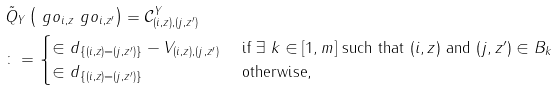Convert formula to latex. <formula><loc_0><loc_0><loc_500><loc_500>& \tilde { Q } _ { Y } \left ( \ g o _ { i , z } \ g o _ { i , z ^ { \prime } } \right ) = \mathcal { C } ^ { Y } _ { ( i , z ) , ( j , z ^ { \prime } ) } \\ & \colon = \begin{cases} \in d _ { \{ ( i , z ) = ( j , z ^ { \prime } ) \} } - V _ { ( i , z ) , ( j , z ^ { \prime } ) } & \text { if } \exists \ k \in [ 1 , m ] \text { such that } ( i , z ) \text { and } ( j , z ^ { \prime } ) \in B _ { k } \\ \in d _ { \{ ( i , z ) = ( j , z ^ { \prime } ) \} } & \text { otherwise,} \end{cases}</formula> 